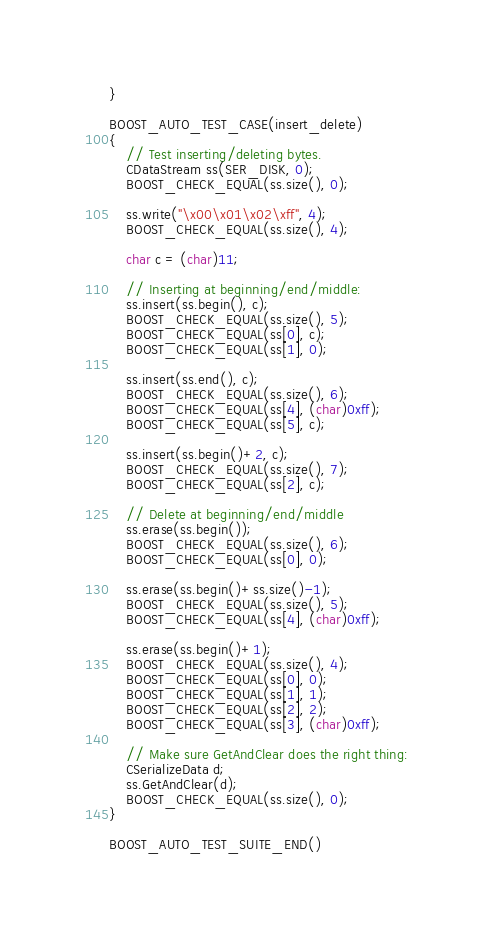<code> <loc_0><loc_0><loc_500><loc_500><_C++_>}

BOOST_AUTO_TEST_CASE(insert_delete)
{
    // Test inserting/deleting bytes.
    CDataStream ss(SER_DISK, 0);
    BOOST_CHECK_EQUAL(ss.size(), 0);

    ss.write("\x00\x01\x02\xff", 4);
    BOOST_CHECK_EQUAL(ss.size(), 4);

    char c = (char)11;

    // Inserting at beginning/end/middle:
    ss.insert(ss.begin(), c);
    BOOST_CHECK_EQUAL(ss.size(), 5);
    BOOST_CHECK_EQUAL(ss[0], c);
    BOOST_CHECK_EQUAL(ss[1], 0);

    ss.insert(ss.end(), c);
    BOOST_CHECK_EQUAL(ss.size(), 6);
    BOOST_CHECK_EQUAL(ss[4], (char)0xff);
    BOOST_CHECK_EQUAL(ss[5], c);

    ss.insert(ss.begin()+2, c);
    BOOST_CHECK_EQUAL(ss.size(), 7);
    BOOST_CHECK_EQUAL(ss[2], c);

    // Delete at beginning/end/middle
    ss.erase(ss.begin());
    BOOST_CHECK_EQUAL(ss.size(), 6);
    BOOST_CHECK_EQUAL(ss[0], 0);

    ss.erase(ss.begin()+ss.size()-1);
    BOOST_CHECK_EQUAL(ss.size(), 5);
    BOOST_CHECK_EQUAL(ss[4], (char)0xff);

    ss.erase(ss.begin()+1);
    BOOST_CHECK_EQUAL(ss.size(), 4);
    BOOST_CHECK_EQUAL(ss[0], 0);
    BOOST_CHECK_EQUAL(ss[1], 1);
    BOOST_CHECK_EQUAL(ss[2], 2);
    BOOST_CHECK_EQUAL(ss[3], (char)0xff);

    // Make sure GetAndClear does the right thing:
    CSerializeData d;
    ss.GetAndClear(d);
    BOOST_CHECK_EQUAL(ss.size(), 0);
}

BOOST_AUTO_TEST_SUITE_END()
</code> 